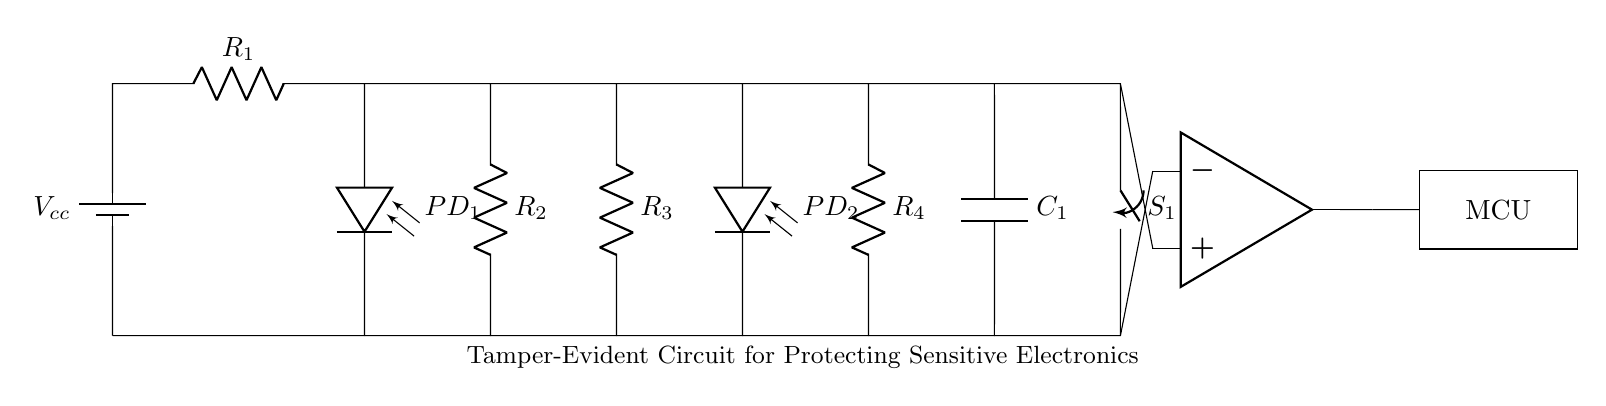What is the main power source of the circuit? The main power source in the circuit is the battery, labeled as Vcc, which provides the necessary voltage to power the components.
Answer: battery How many resistors are present in the circuit? There are four resistors in the circuit, labeled as R1, R2, R3, and R4. Each resistor is connected in various configurations throughout the diagram.
Answer: four What are the two types of sensors used in the circuit? The two types of sensors used in the circuit are photodiodes, labeled as PD1 and PD2. These sensors are responsible for detecting light and contributing to the tamper-evidence mechanism.
Answer: photodiodes What component connects the output to the microcontroller? The op-amp connects the output of the circuit to the microcontroller, acting as an amplifier to process the signals detected by the circuit.
Answer: op-amp What happens when switch S1 is closed? When switch S1 is closed, it completes the circuit allowing current to flow, enabling the operation of the connected components including the main sensors and microcontroller.
Answer: completes circuit What is the function of capacitor C1 in the circuit? Capacitor C1 is used for filtering or stabilizing the voltage in the circuit, preventing sudden changes and ensuring smooth operation of the circuit under typical conditions.
Answer: filtering 